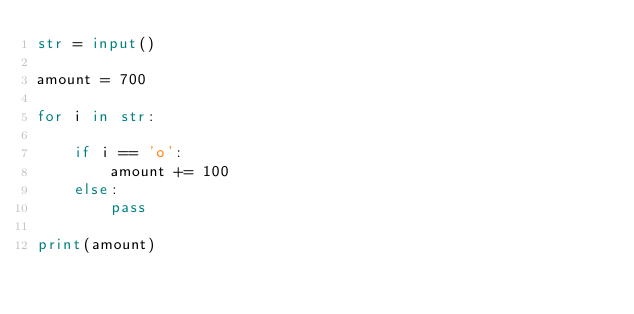<code> <loc_0><loc_0><loc_500><loc_500><_Python_>str = input()

amount = 700

for i in str:

    if i == 'o':
        amount += 100
    else:
        pass

print(amount)
</code> 